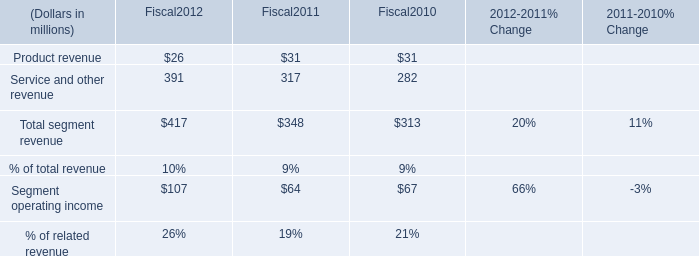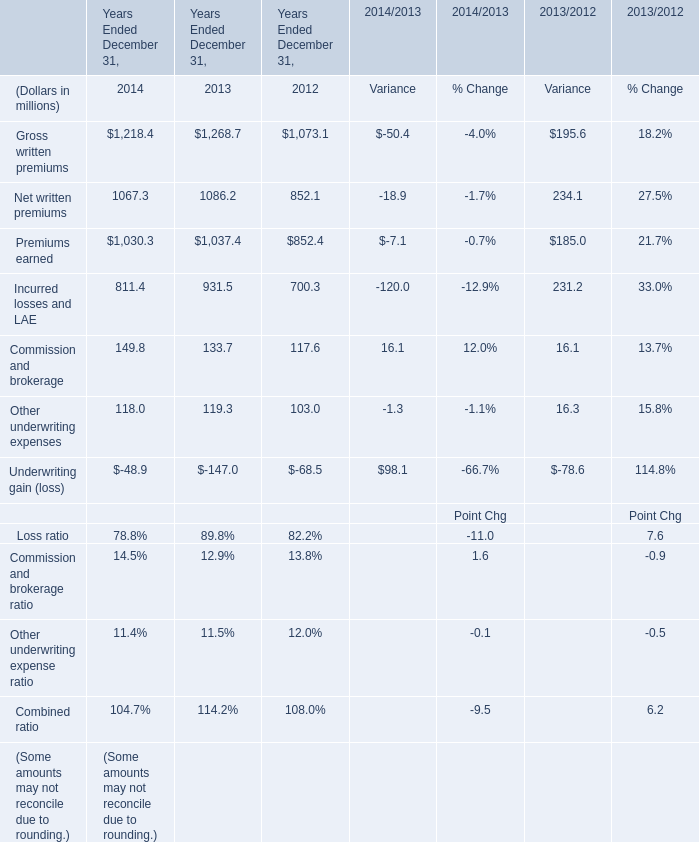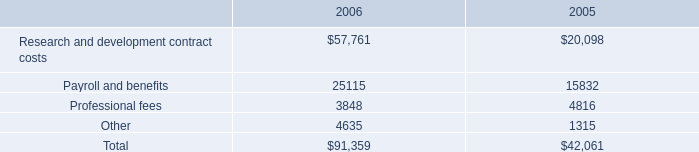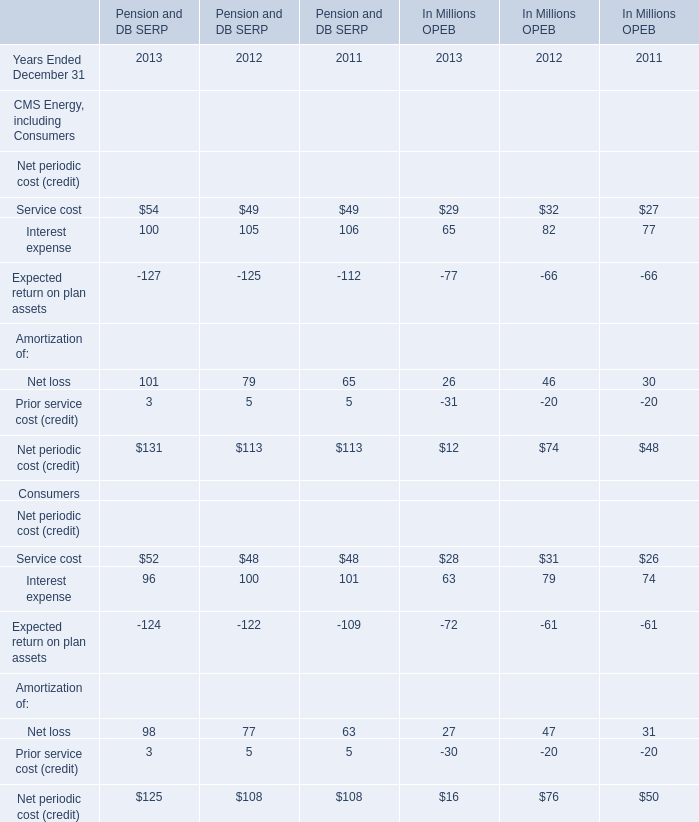If Premiums earned develops with the same growth rate in 2014, what will it reach in 2015? (in million) 
Computations: ((((1030.3 - 1037.4) / 1030.3) * 1030.3) + 1030.3)
Answer: 1023.2. 